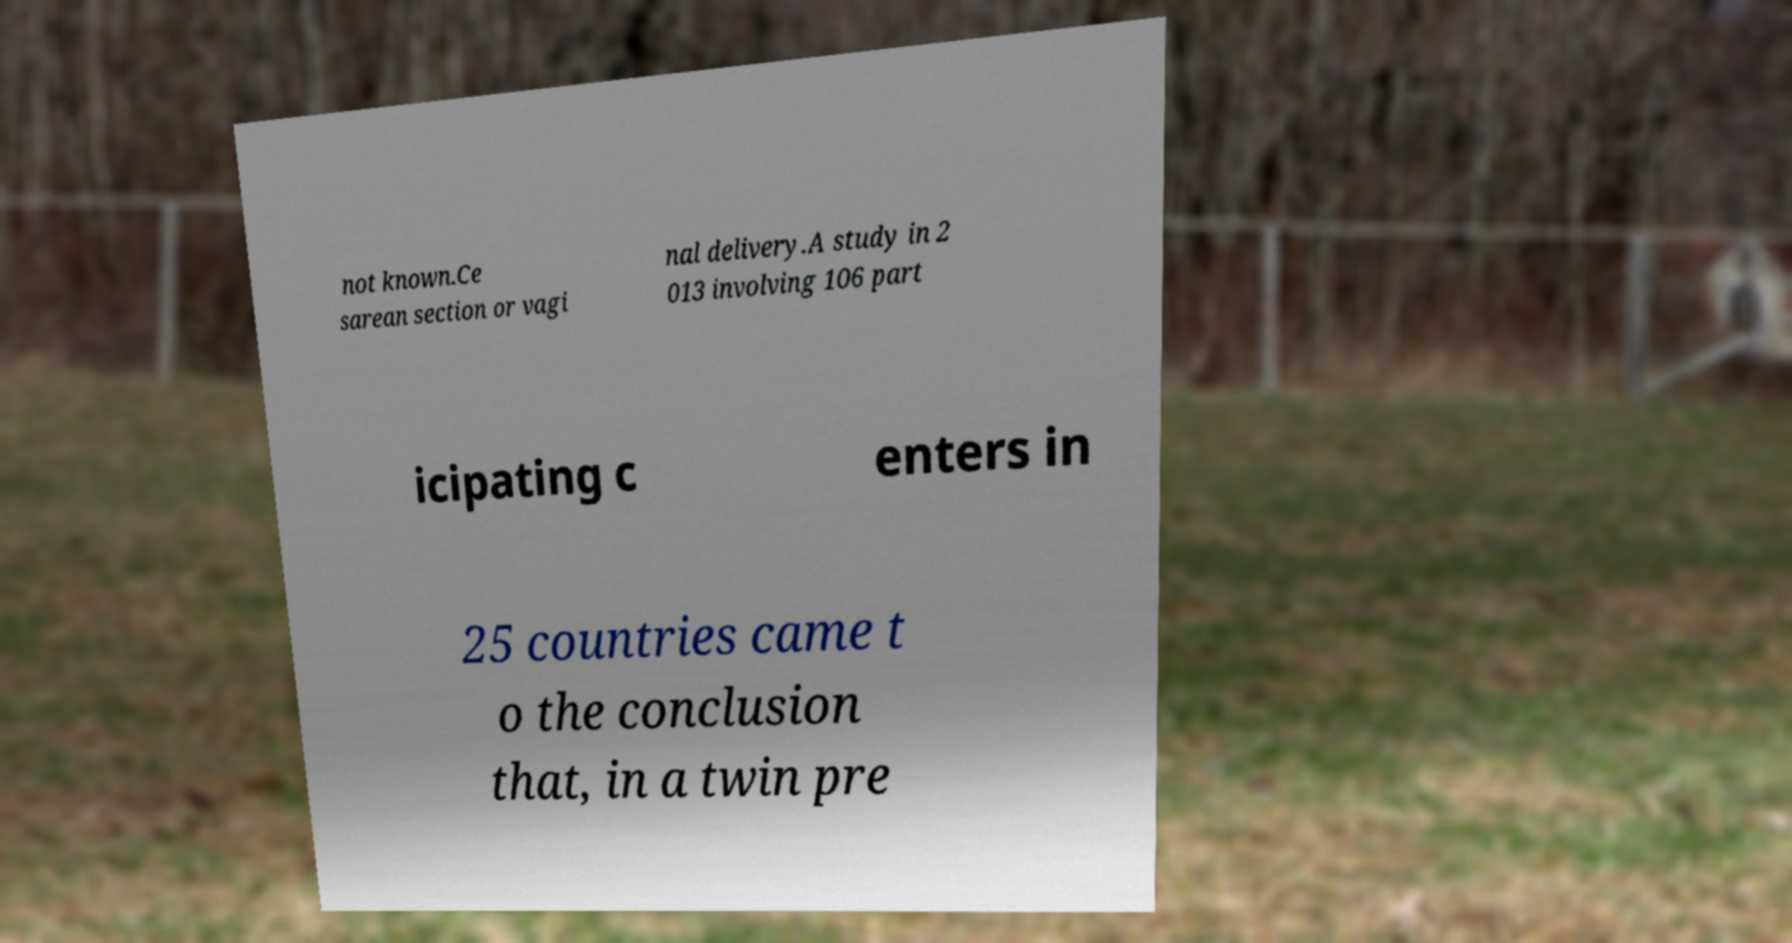I need the written content from this picture converted into text. Can you do that? not known.Ce sarean section or vagi nal delivery.A study in 2 013 involving 106 part icipating c enters in 25 countries came t o the conclusion that, in a twin pre 